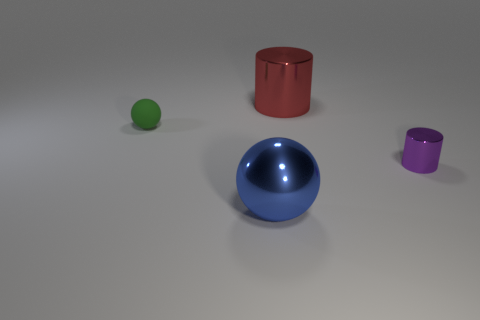Is there anything else that has the same material as the green thing?
Offer a very short reply. No. Do the sphere that is behind the blue sphere and the small purple thing have the same material?
Give a very brief answer. No. Are there any things behind the blue shiny object?
Offer a very short reply. Yes. What is the color of the small thing that is to the right of the sphere on the right side of the ball left of the blue thing?
Give a very brief answer. Purple. There is another metallic thing that is the same size as the red object; what is its shape?
Your response must be concise. Sphere. Is the number of large blue balls greater than the number of big green things?
Make the answer very short. Yes. Are there any green rubber balls that are behind the sphere to the right of the small green rubber sphere?
Provide a short and direct response. Yes. What is the color of the small metallic object that is the same shape as the large red object?
Offer a terse response. Purple. What color is the other cylinder that is the same material as the red cylinder?
Keep it short and to the point. Purple. There is a big metallic object in front of the large object that is behind the shiny sphere; are there any red shiny cylinders behind it?
Offer a very short reply. Yes. 